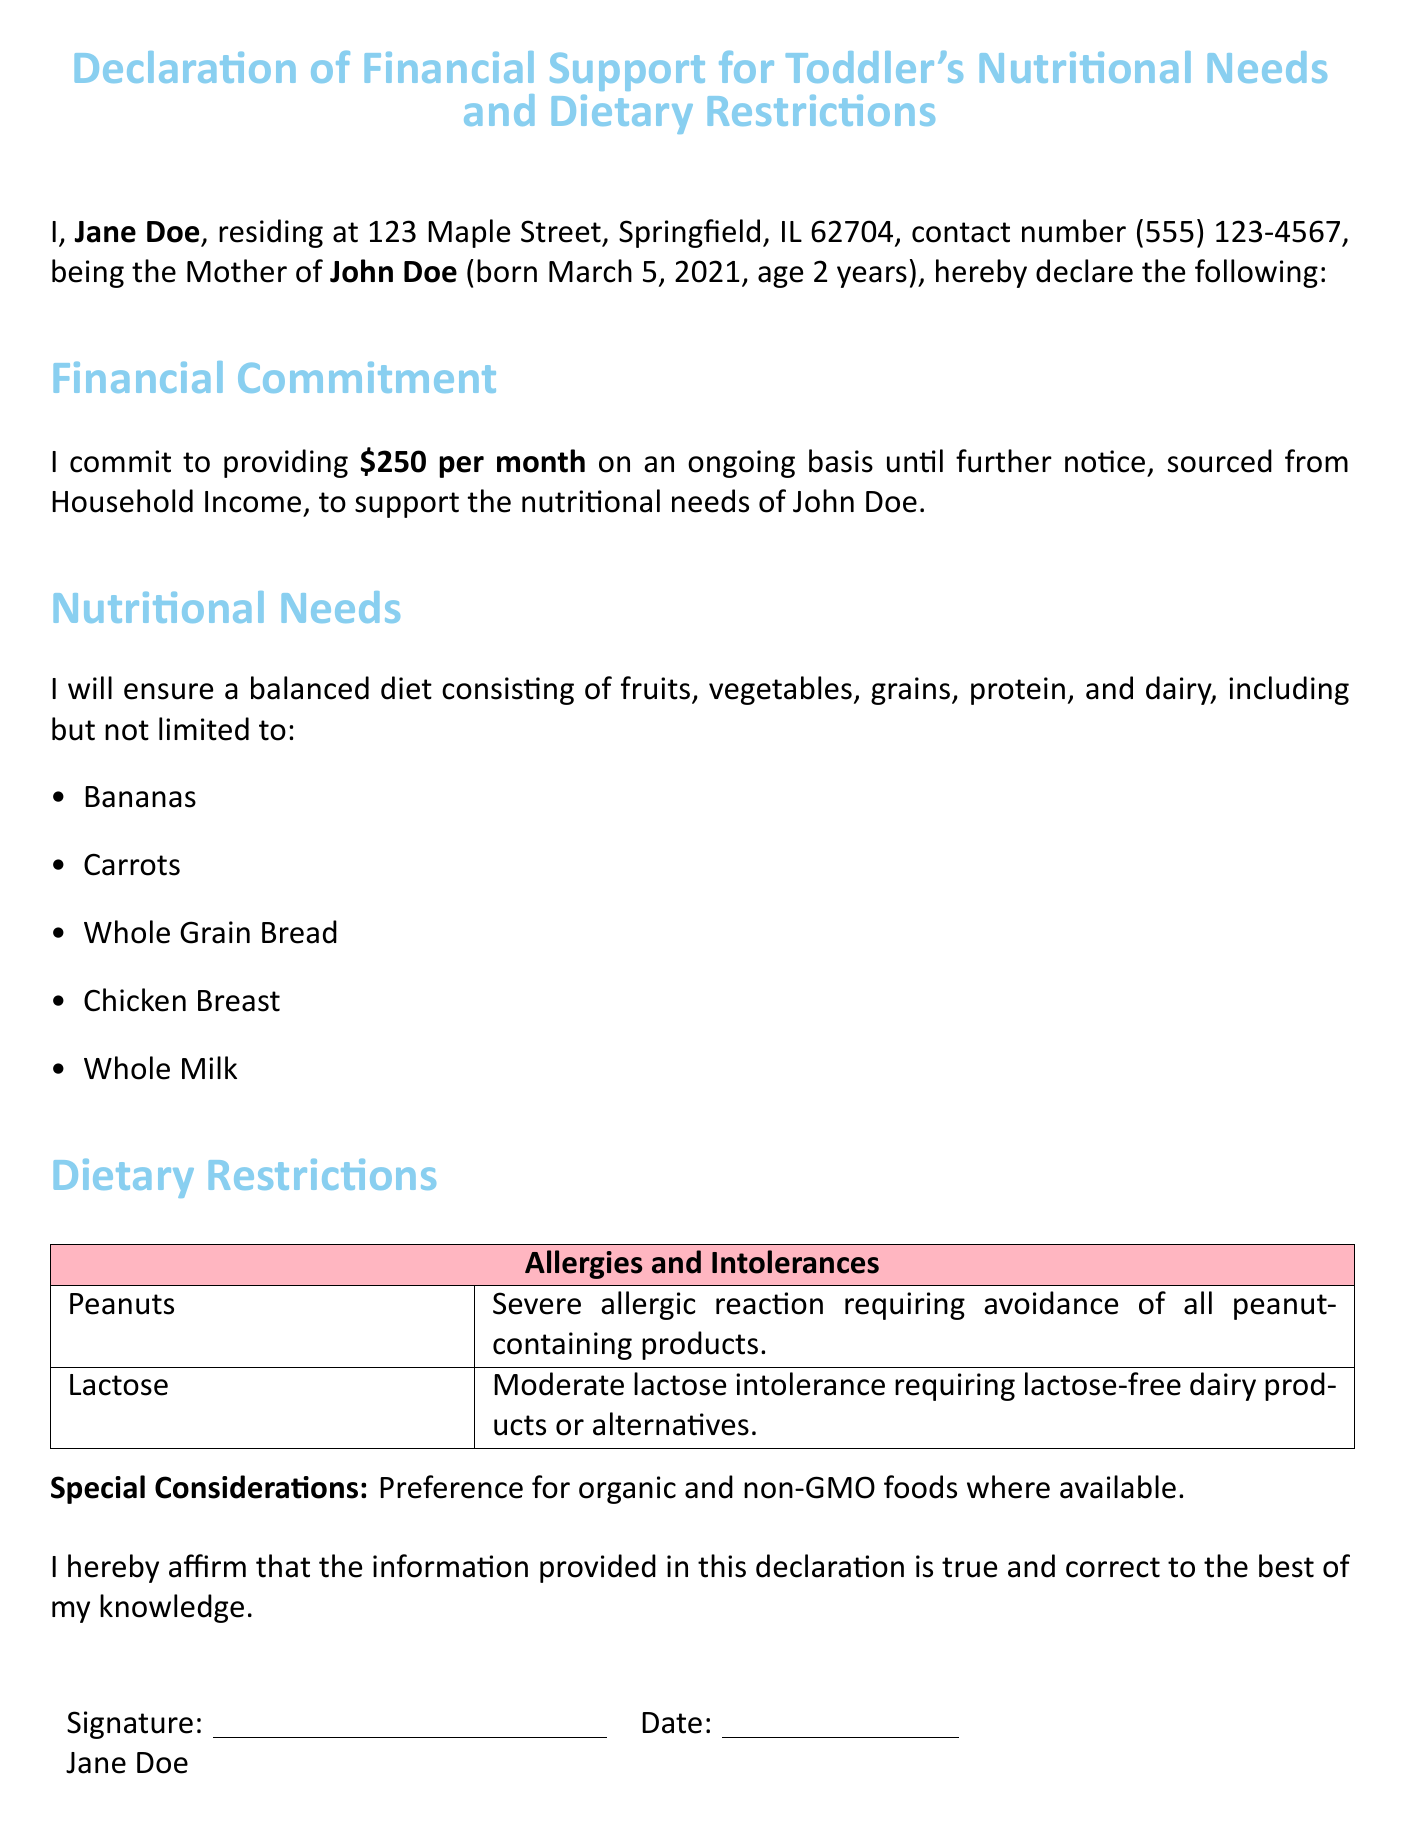What is the name of the mother? The document states the mother's name at the beginning: Jane Doe.
Answer: Jane Doe What is the monthly financial commitment? This information is outlined in the financial commitment section, which specifies $250 per month.
Answer: $250 per month What allergies does John have? The allergies are listed in the dietary restrictions section, where peanuts are mentioned.
Answer: Peanuts What is John’s date of birth? The document includes John’s birth date in the introductory statement: March 5, 2021.
Answer: March 5, 2021 What type of milk does John require? The nutritional needs section implies the need for lactose-free dairy or alternatives due to lactose intolerance.
Answer: Lactose-free milk What is the priority for food sourcing mentioned? The special considerations section indicates a preference for organic and non-GMO foods.
Answer: Organic and non-GMO Who is the declaration for? The document indicates John Doe as the child referenced in the declaration.
Answer: John Doe What is the contact number provided? The contact information given includes a specific phone number: (555) 123-4567.
Answer: (555) 123-4567 